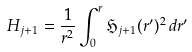Convert formula to latex. <formula><loc_0><loc_0><loc_500><loc_500>H _ { j + 1 } = \frac { 1 } { r ^ { 2 } } \int _ { 0 } ^ { r } \mathfrak { H } _ { j + 1 } ( r ^ { \prime } ) ^ { 2 } \, d r ^ { \prime }</formula> 